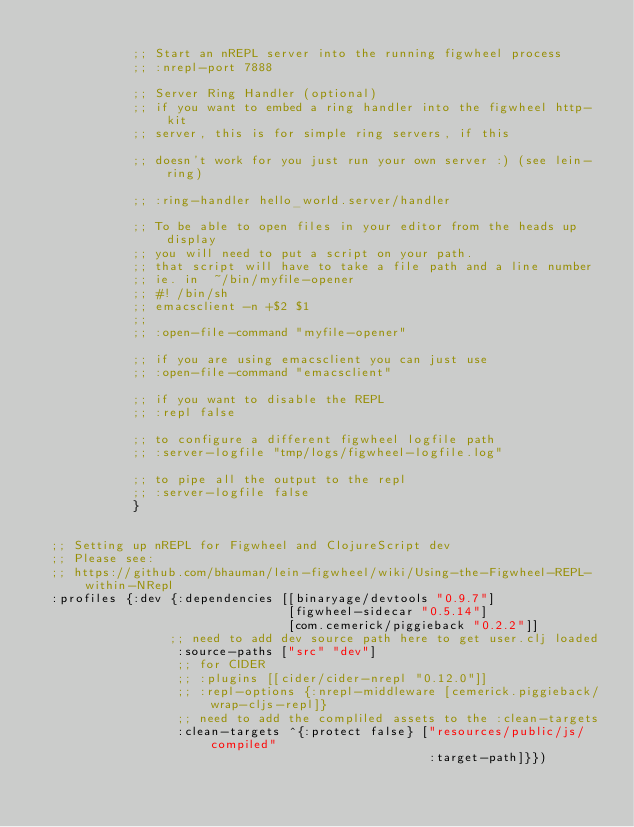Convert code to text. <code><loc_0><loc_0><loc_500><loc_500><_Clojure_>
             ;; Start an nREPL server into the running figwheel process
             ;; :nrepl-port 7888

             ;; Server Ring Handler (optional)
             ;; if you want to embed a ring handler into the figwheel http-kit
             ;; server, this is for simple ring servers, if this

             ;; doesn't work for you just run your own server :) (see lein-ring)

             ;; :ring-handler hello_world.server/handler

             ;; To be able to open files in your editor from the heads up display
             ;; you will need to put a script on your path.
             ;; that script will have to take a file path and a line number
             ;; ie. in  ~/bin/myfile-opener
             ;; #! /bin/sh
             ;; emacsclient -n +$2 $1
             ;;
             ;; :open-file-command "myfile-opener"

             ;; if you are using emacsclient you can just use
             ;; :open-file-command "emacsclient"

             ;; if you want to disable the REPL
             ;; :repl false

             ;; to configure a different figwheel logfile path
             ;; :server-logfile "tmp/logs/figwheel-logfile.log"

             ;; to pipe all the output to the repl
             ;; :server-logfile false
             }


  ;; Setting up nREPL for Figwheel and ClojureScript dev
  ;; Please see:
  ;; https://github.com/bhauman/lein-figwheel/wiki/Using-the-Figwheel-REPL-within-NRepl
  :profiles {:dev {:dependencies [[binaryage/devtools "0.9.7"]
                                  [figwheel-sidecar "0.5.14"]
                                  [com.cemerick/piggieback "0.2.2"]]
                  ;; need to add dev source path here to get user.clj loaded
                   :source-paths ["src" "dev"]
                   ;; for CIDER
                   ;; :plugins [[cider/cider-nrepl "0.12.0"]]
                   ;; :repl-options {:nrepl-middleware [cemerick.piggieback/wrap-cljs-repl]}
                   ;; need to add the compliled assets to the :clean-targets
                   :clean-targets ^{:protect false} ["resources/public/js/compiled"
                                                     :target-path]}})
</code> 